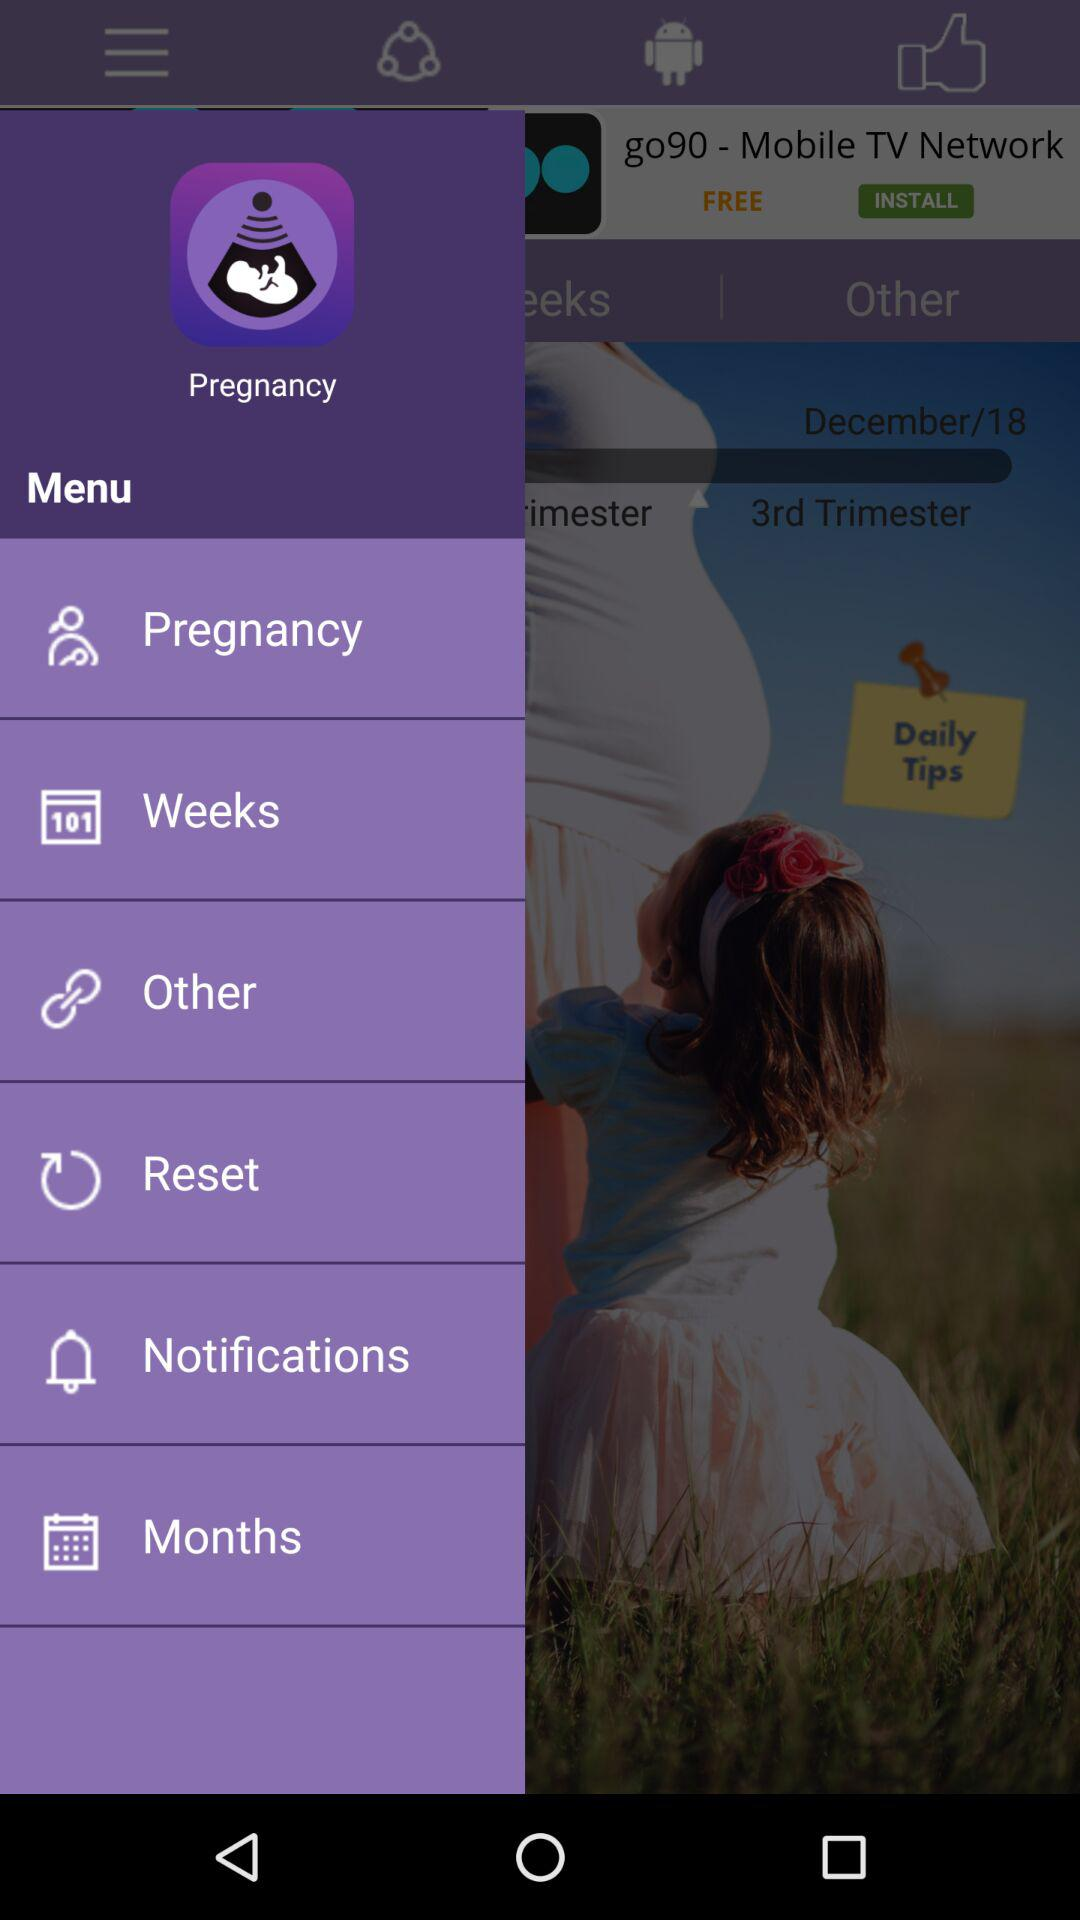What is the application name? The application name is "Pregnancy Tracker". 